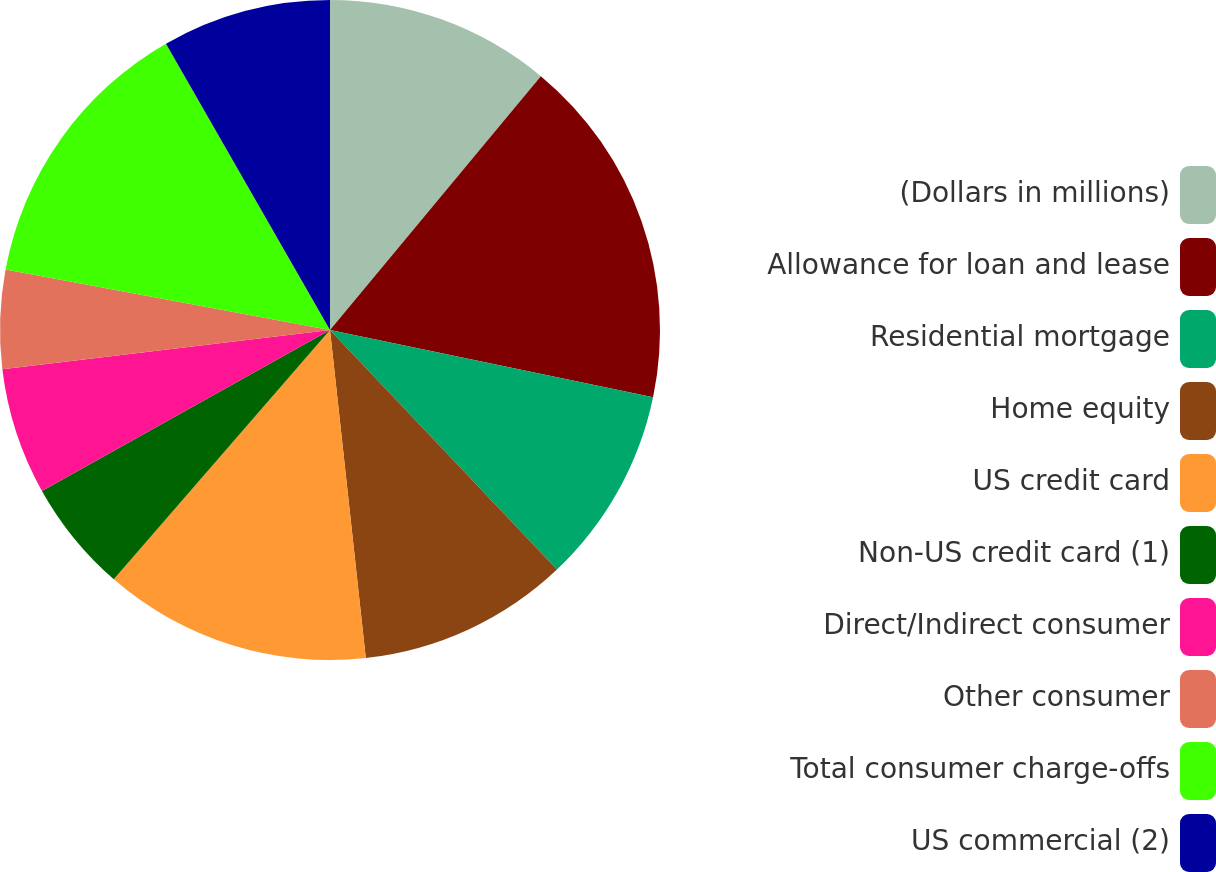<chart> <loc_0><loc_0><loc_500><loc_500><pie_chart><fcel>(Dollars in millions)<fcel>Allowance for loan and lease<fcel>Residential mortgage<fcel>Home equity<fcel>US credit card<fcel>Non-US credit card (1)<fcel>Direct/Indirect consumer<fcel>Other consumer<fcel>Total consumer charge-offs<fcel>US commercial (2)<nl><fcel>11.03%<fcel>17.24%<fcel>9.66%<fcel>10.34%<fcel>13.1%<fcel>5.52%<fcel>6.21%<fcel>4.83%<fcel>13.79%<fcel>8.28%<nl></chart> 